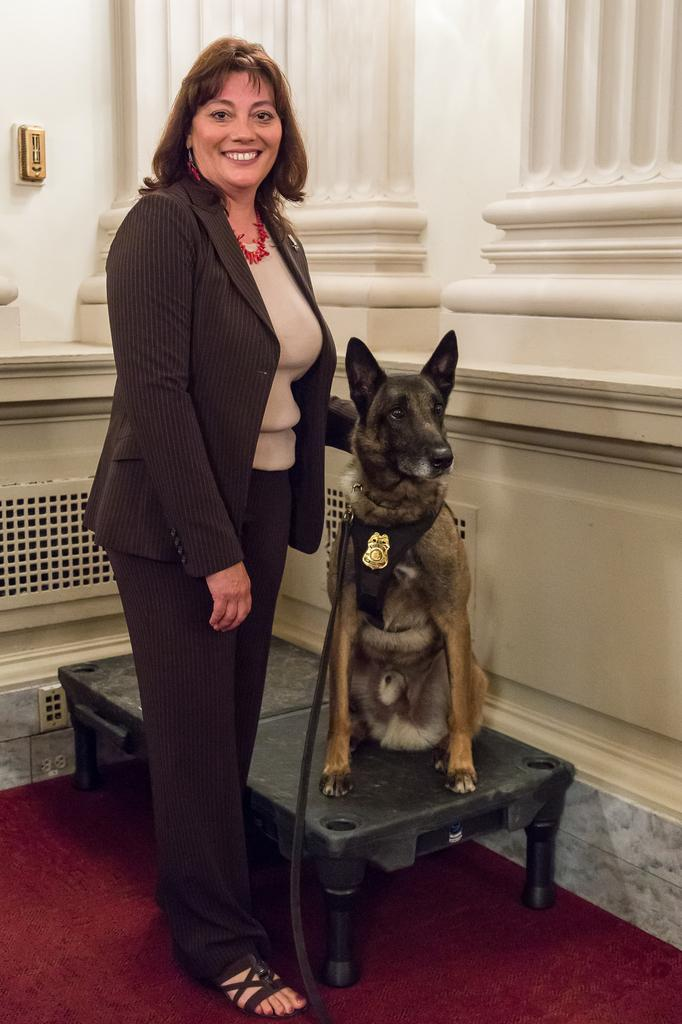Who is the main subject in the image? There is a woman in the image. What is the woman holding in the image? The woman is holding a dog. Where is the woman located in the image? The woman is standing in the middle of the image. What expression does the woman have? The woman is smiling. What can be seen behind the woman in the image? There is a wall behind the woman. What type of mint is growing on the wall behind the woman in the image? There is no mint visible in the image; only a wall can be seen behind the woman. 